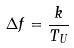<formula> <loc_0><loc_0><loc_500><loc_500>\Delta f = \frac { k } { T _ { U } }</formula> 